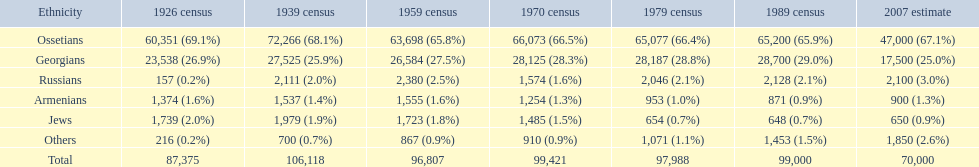In 1926, which population had the highest number of individuals? Ossetians. 